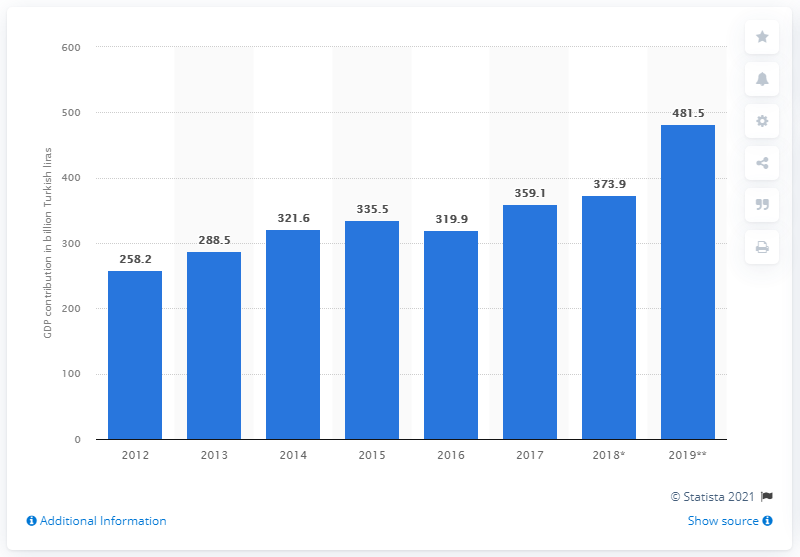Give some essential details in this illustration. In 2012, the travel and tourism industry contributed 258.2 billion Turkish lira to Turkey's Gross Domestic Product. In 2019, the travel and tourism industry contributed 481.5 billion Turkish liras to the country's GDP. 